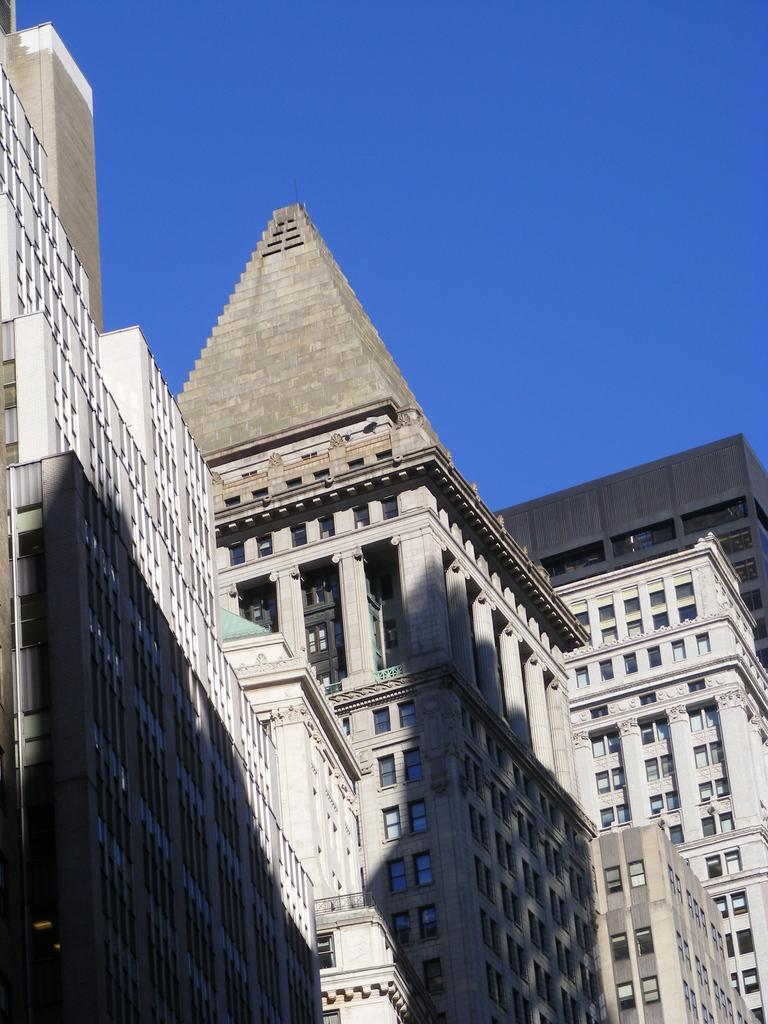What type of structures are present in the image? There are buildings in the image. What can be seen at the top of the image? The sky is visible at the top of the image. What feature is present on the buildings? There are glass windows on the buildings. What type of berry can be seen growing on the buildings in the image? There are no berries present on the buildings in the image. Can you describe the animal that is arguing with the buildings in the image? There are no animals or arguments depicted in the image; it only features buildings and the sky. 